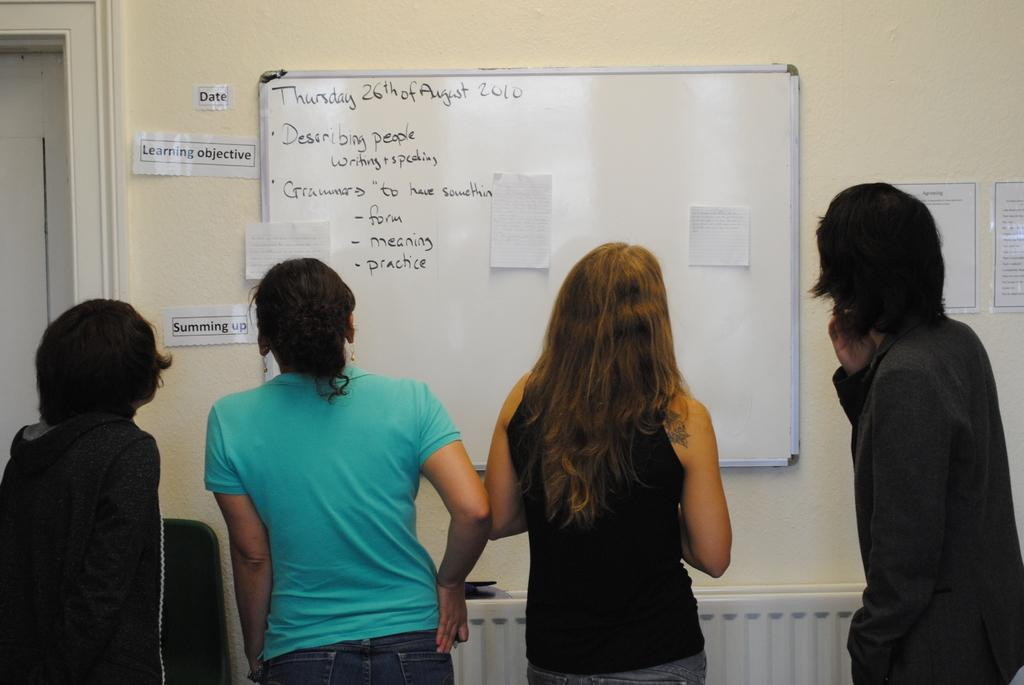How many people are in the image? There are four persons standing in the center of the image. What can be seen in the background of the image? There is a wall in the background of the image, with posters and a board with text. Are there any other objects visible in the background? Yes, there are a few other objects in the background of the image. Can you tell me what type of soap is being used by the monkey in the image? There is no monkey present in the image, and therefore no soap or monkey-related activities can be observed. 